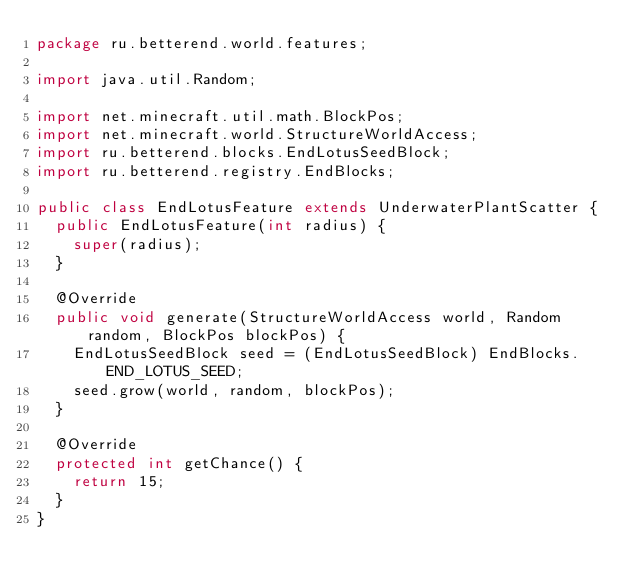Convert code to text. <code><loc_0><loc_0><loc_500><loc_500><_Java_>package ru.betterend.world.features;

import java.util.Random;

import net.minecraft.util.math.BlockPos;
import net.minecraft.world.StructureWorldAccess;
import ru.betterend.blocks.EndLotusSeedBlock;
import ru.betterend.registry.EndBlocks;

public class EndLotusFeature extends UnderwaterPlantScatter {
	public EndLotusFeature(int radius) {
		super(radius);
	}

	@Override
	public void generate(StructureWorldAccess world, Random random, BlockPos blockPos) {
		EndLotusSeedBlock seed = (EndLotusSeedBlock) EndBlocks.END_LOTUS_SEED;
		seed.grow(world, random, blockPos);
	}
	
	@Override
	protected int getChance() {
		return 15;
	}
}
</code> 